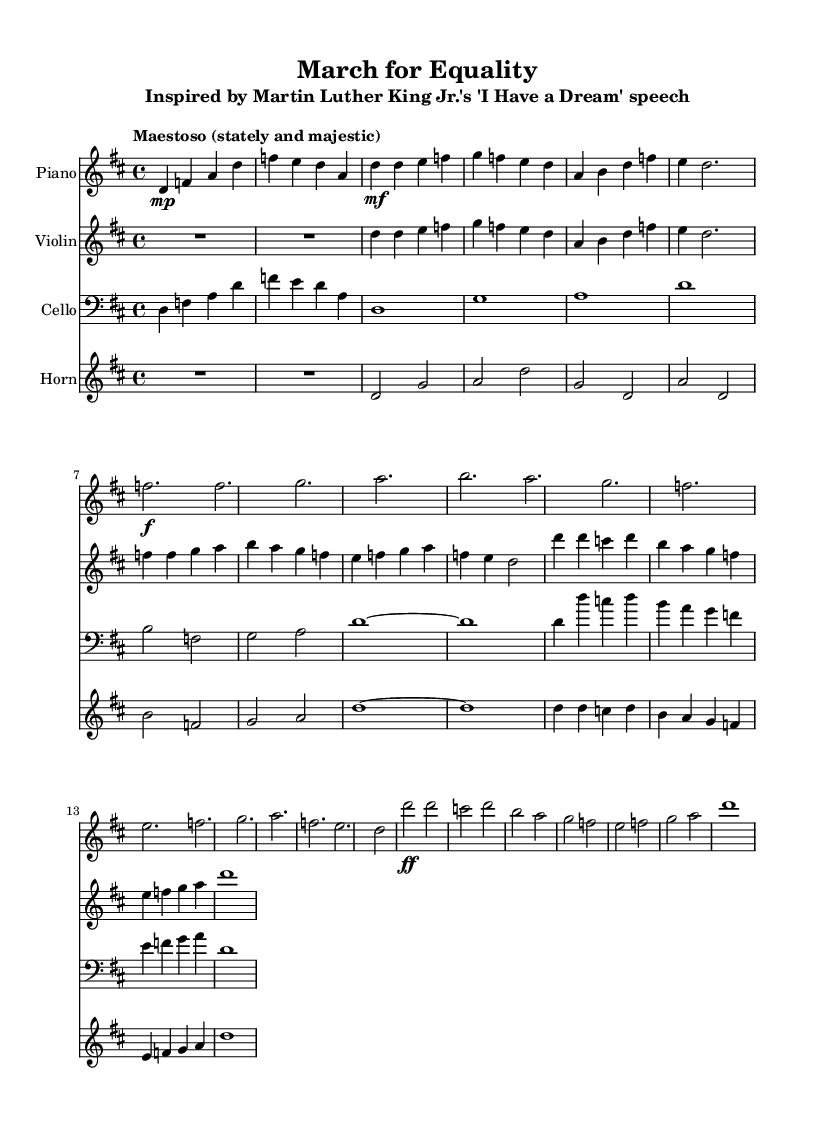What is the key signature of this music? The key signature is indicated at the beginning of the score and is D major, which has two sharps (F# and C#).
Answer: D major What is the time signature of this music? The time signature is found at the beginning of the score, displayed as 4/4, which indicates there are four beats per measure.
Answer: 4/4 What is the tempo marking of the piece? The tempo is specified in the score, shown as "Maestoso," which indicates that the music should be played stately and majestic.
Answer: Maestoso How many measures are there in the introduction? The introduction is a section of the music before the main themes begin, and by counting the measures in that part, it consists of two measures.
Answer: 2 Which instrument has a melody in the first theme? The first theme of the piece can be identified by observing the clefs and the notes played; the violin carries the melody in the first theme.
Answer: Violin What notes are played in the climax section? By examining the written notes in the climax section specifically, the notes are D, C, D, B, A, G, F, E, F, G, A, D.
Answer: D, C, D, B, A, G, F, E, F, G, A, D How many staff members are used in this score? The score features a total of four staves, corresponding to the instruments used: piano, violin, cello, and horn.
Answer: 4 